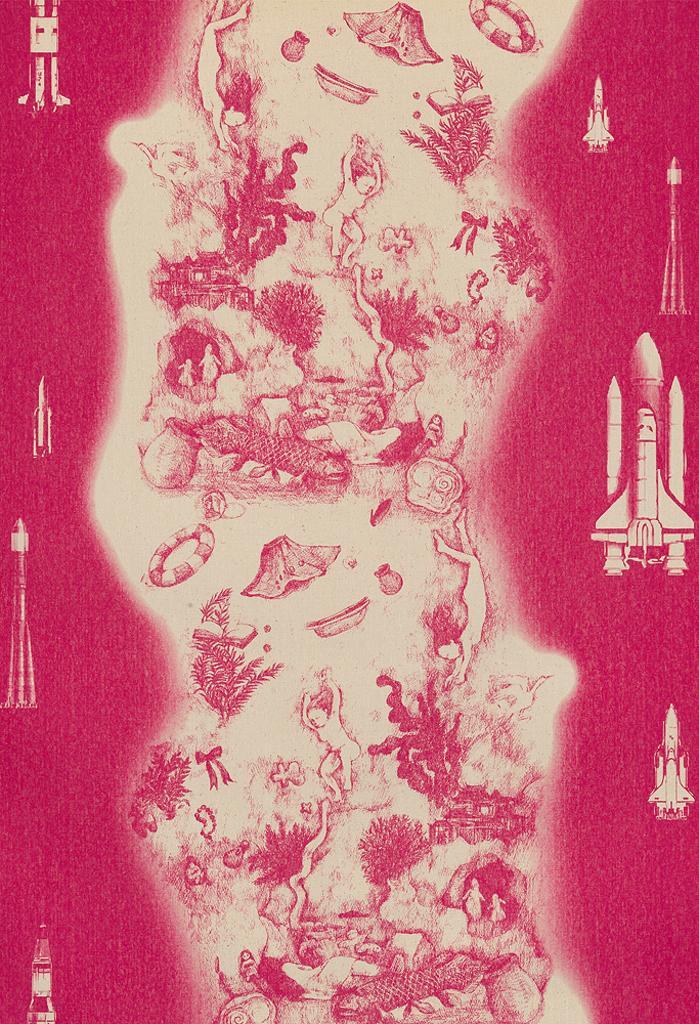How would you summarize this image in a sentence or two? This is an edited picture. In this image there are rockets and there are plants and there are people and there are objects. 